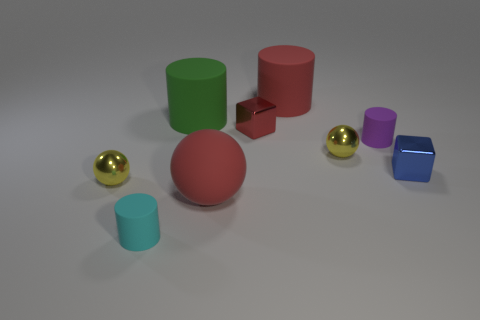What number of objects are either large matte cylinders or large yellow rubber cylinders?
Ensure brevity in your answer.  2. What is the shape of the red rubber thing in front of the tiny matte cylinder to the right of the big red matte sphere?
Give a very brief answer. Sphere. Do the large red matte thing that is behind the green cylinder and the blue shiny thing have the same shape?
Provide a succinct answer. No. What size is the red sphere that is made of the same material as the purple object?
Provide a succinct answer. Large. How many things are either cylinders on the left side of the small purple rubber cylinder or metallic spheres that are to the right of the cyan object?
Ensure brevity in your answer.  4. Are there an equal number of matte objects that are behind the big red matte sphere and small things that are right of the purple cylinder?
Offer a very short reply. No. What color is the small metal sphere that is on the left side of the tiny cyan rubber thing?
Your response must be concise. Yellow. There is a large rubber ball; is its color the same as the small object right of the purple matte thing?
Your answer should be compact. No. Are there fewer red cylinders than yellow spheres?
Your response must be concise. Yes. Is the color of the tiny sphere to the right of the red metallic block the same as the large rubber sphere?
Provide a succinct answer. No. 